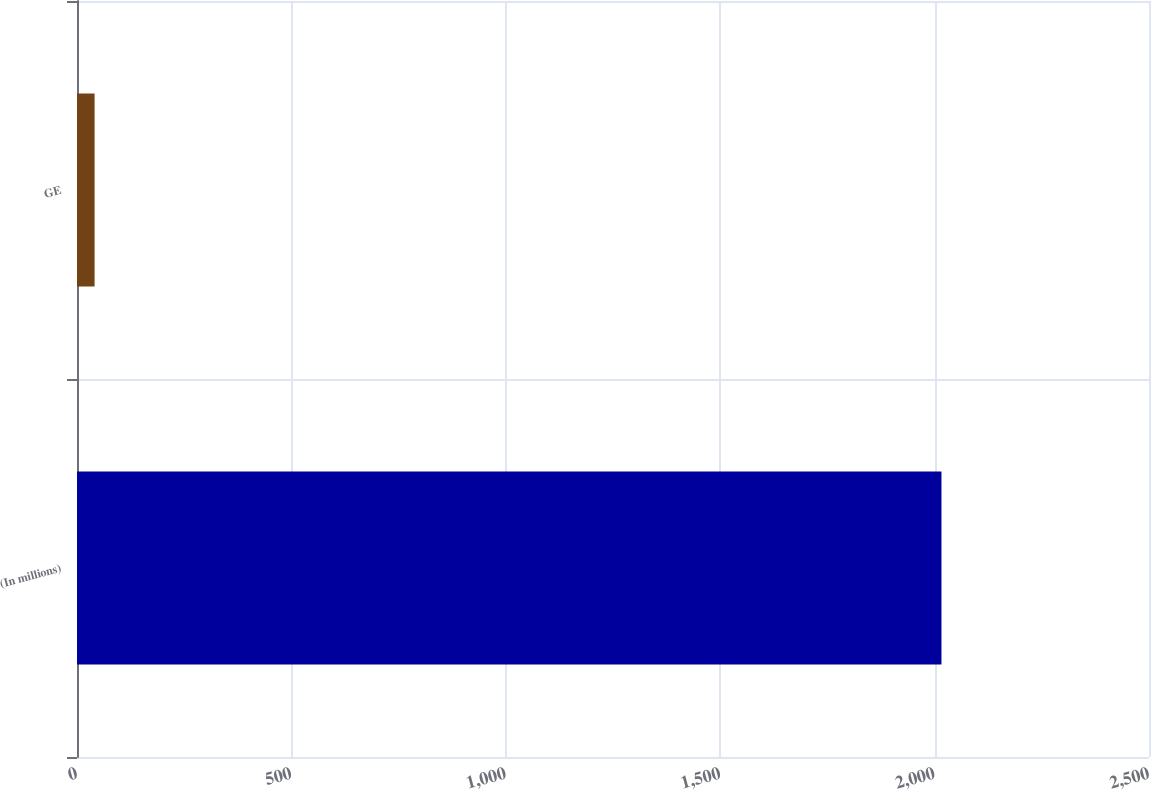Convert chart to OTSL. <chart><loc_0><loc_0><loc_500><loc_500><bar_chart><fcel>(In millions)<fcel>GE<nl><fcel>2016<fcel>41<nl></chart> 